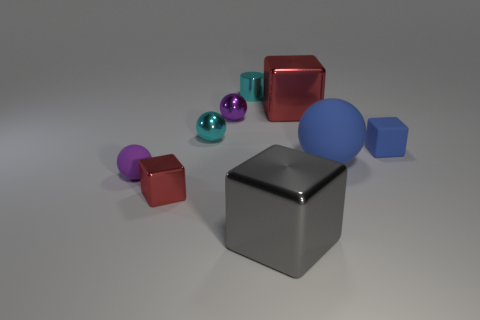Do the big matte object and the tiny rubber object to the right of the cyan metallic cylinder have the same color?
Offer a terse response. Yes. What is the size of the matte block that is the same color as the large ball?
Your answer should be compact. Small. There is a big thing that is the same color as the tiny metal block; what is it made of?
Give a very brief answer. Metal. Are there any small objects of the same color as the big rubber thing?
Your response must be concise. Yes. What number of rubber objects are big blue objects or tiny blue objects?
Keep it short and to the point. 2. Are there any large cylinders that have the same material as the big red cube?
Provide a short and direct response. No. How many rubber spheres are both on the left side of the tiny cyan shiny cylinder and to the right of the cylinder?
Offer a very short reply. 0. Are there fewer blue rubber spheres that are behind the small cyan sphere than big shiny cubes behind the big ball?
Provide a succinct answer. Yes. Is the small purple matte thing the same shape as the large rubber object?
Make the answer very short. Yes. How many other objects are there of the same size as the shiny cylinder?
Provide a succinct answer. 5. 